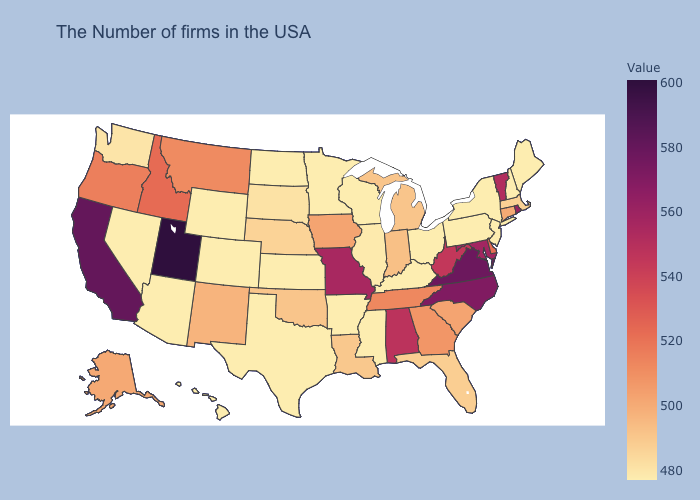Which states have the highest value in the USA?
Short answer required. Utah. Does Arizona have a lower value than Georgia?
Quick response, please. Yes. Does Indiana have the highest value in the MidWest?
Write a very short answer. No. Does Utah have the highest value in the USA?
Give a very brief answer. Yes. Among the states that border Virginia , which have the lowest value?
Keep it brief. Kentucky. Does Utah have the highest value in the West?
Short answer required. Yes. Among the states that border Arkansas , which have the highest value?
Be succinct. Missouri. Among the states that border Nevada , does Arizona have the highest value?
Quick response, please. No. 